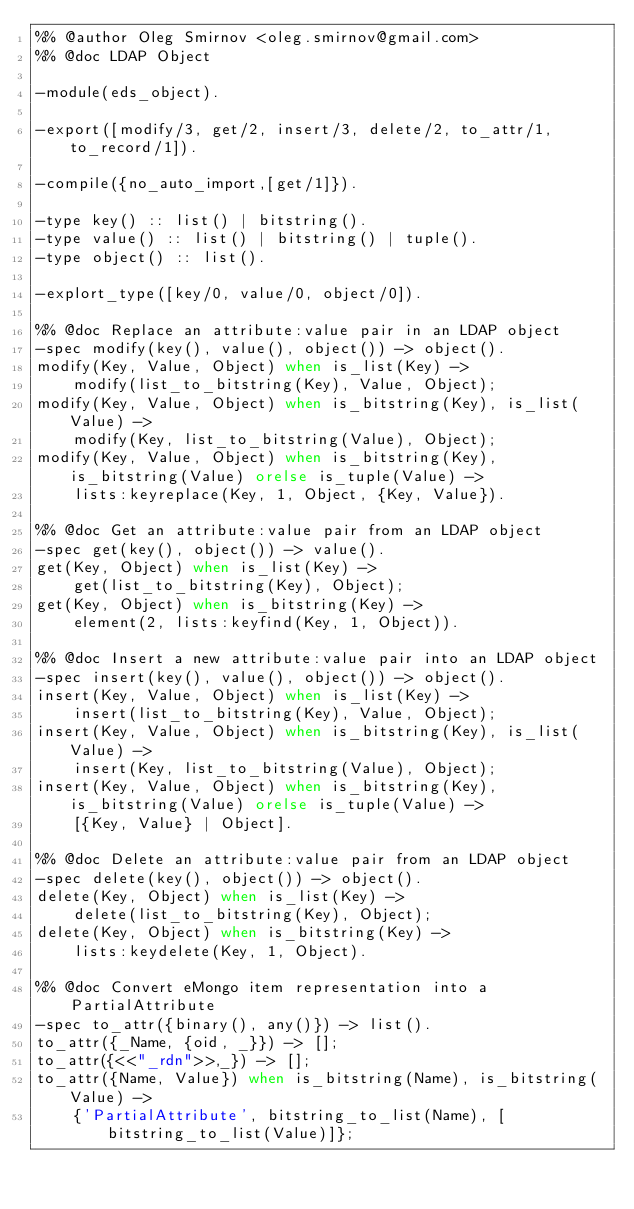<code> <loc_0><loc_0><loc_500><loc_500><_Erlang_>%% @author Oleg Smirnov <oleg.smirnov@gmail.com>
%% @doc LDAP Object

-module(eds_object).

-export([modify/3, get/2, insert/3, delete/2, to_attr/1, to_record/1]).

-compile({no_auto_import,[get/1]}).

-type key() :: list() | bitstring().
-type value() :: list() | bitstring() | tuple().
-type object() :: list().

-explort_type([key/0, value/0, object/0]).

%% @doc Replace an attribute:value pair in an LDAP object
-spec modify(key(), value(), object()) -> object().
modify(Key, Value, Object) when is_list(Key) ->
    modify(list_to_bitstring(Key), Value, Object);
modify(Key, Value, Object) when is_bitstring(Key), is_list(Value) ->
    modify(Key, list_to_bitstring(Value), Object);
modify(Key, Value, Object) when is_bitstring(Key), is_bitstring(Value) orelse is_tuple(Value) ->
    lists:keyreplace(Key, 1, Object, {Key, Value}).

%% @doc Get an attribute:value pair from an LDAP object
-spec get(key(), object()) -> value().
get(Key, Object) when is_list(Key) ->
    get(list_to_bitstring(Key), Object);
get(Key, Object) when is_bitstring(Key) ->
    element(2, lists:keyfind(Key, 1, Object)).

%% @doc Insert a new attribute:value pair into an LDAP object
-spec insert(key(), value(), object()) -> object().
insert(Key, Value, Object) when is_list(Key) ->
    insert(list_to_bitstring(Key), Value, Object);
insert(Key, Value, Object) when is_bitstring(Key), is_list(Value) ->
    insert(Key, list_to_bitstring(Value), Object);
insert(Key, Value, Object) when is_bitstring(Key), is_bitstring(Value) orelse is_tuple(Value) ->
    [{Key, Value} | Object].

%% @doc Delete an attribute:value pair from an LDAP object
-spec delete(key(), object()) -> object().
delete(Key, Object) when is_list(Key) ->
    delete(list_to_bitstring(Key), Object);
delete(Key, Object) when is_bitstring(Key) ->
    lists:keydelete(Key, 1, Object).

%% @doc Convert eMongo item representation into a PartialAttribute
-spec to_attr({binary(), any()}) -> list().
to_attr({_Name, {oid, _}}) -> [];
to_attr({<<"_rdn">>,_}) -> [];
to_attr({Name, Value}) when is_bitstring(Name), is_bitstring(Value) ->
    {'PartialAttribute', bitstring_to_list(Name), [bitstring_to_list(Value)]};</code> 